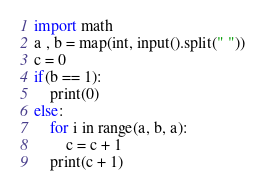<code> <loc_0><loc_0><loc_500><loc_500><_Python_>import math
a , b = map(int, input().split(" "))
c = 0
if(b == 1):
    print(0)
else:
    for i in range(a, b, a):
        c = c + 1
    print(c + 1)</code> 